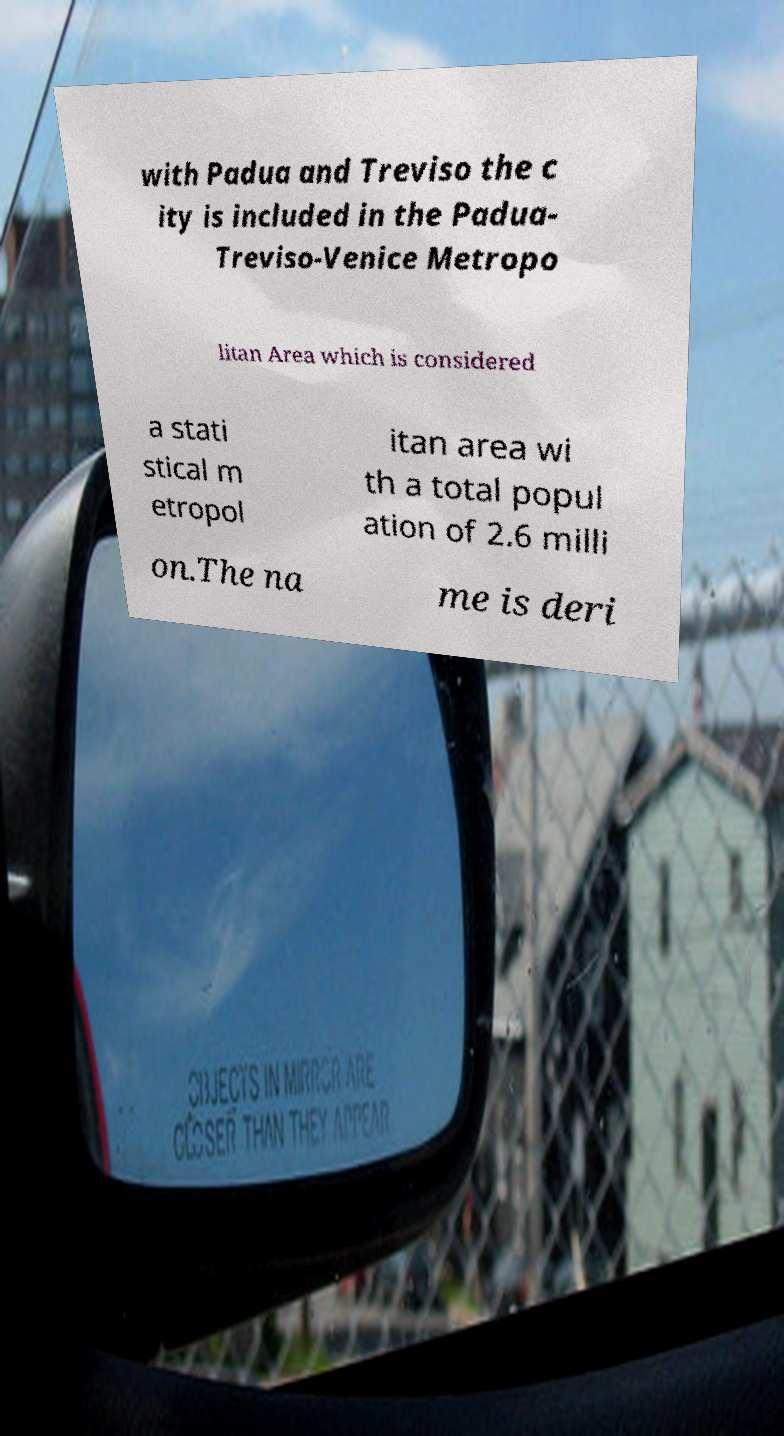There's text embedded in this image that I need extracted. Can you transcribe it verbatim? with Padua and Treviso the c ity is included in the Padua- Treviso-Venice Metropo litan Area which is considered a stati stical m etropol itan area wi th a total popul ation of 2.6 milli on.The na me is deri 